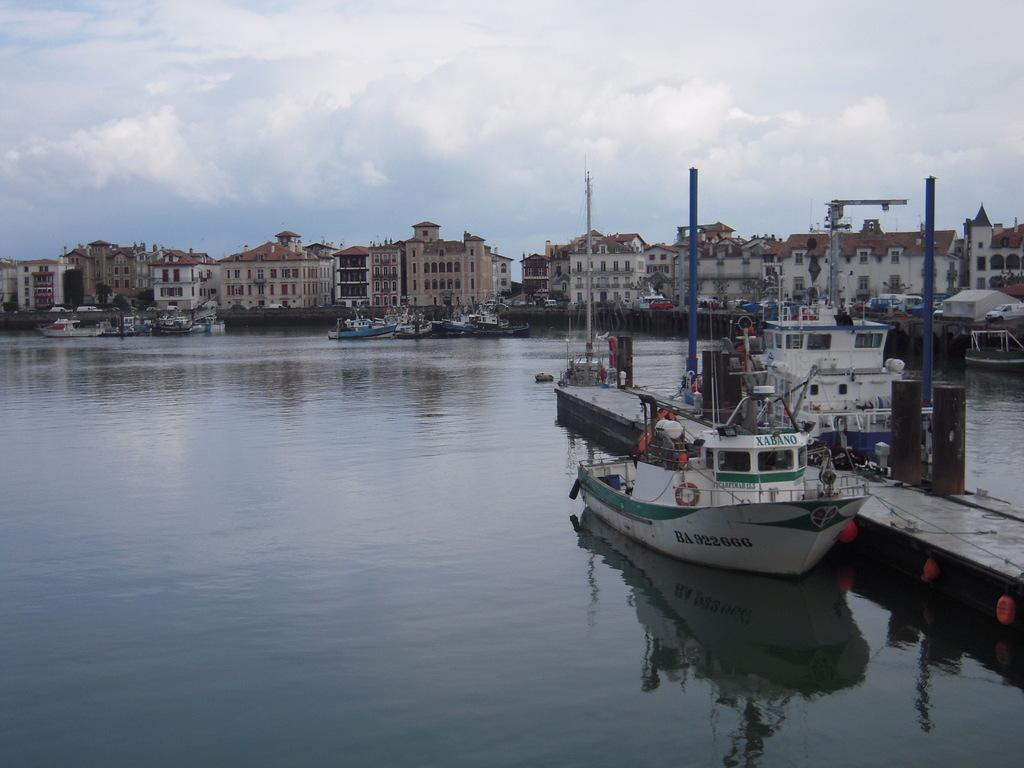<image>
Give a short and clear explanation of the subsequent image. A boat named Xabano is docked in the marina on a cloudy day 